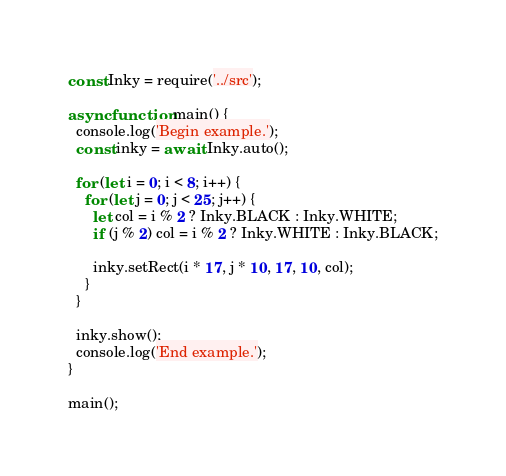<code> <loc_0><loc_0><loc_500><loc_500><_JavaScript_>const Inky = require('../src');

async function main() {
  console.log('Begin example.');
  const inky = await Inky.auto();

  for (let i = 0; i < 8; i++) {
    for (let j = 0; j < 25; j++) {
      let col = i % 2 ? Inky.BLACK : Inky.WHITE;
      if (j % 2) col = i % 2 ? Inky.WHITE : Inky.BLACK;

      inky.setRect(i * 17, j * 10, 17, 10, col);
    }
  }

  inky.show();
  console.log('End example.');
}

main();
</code> 